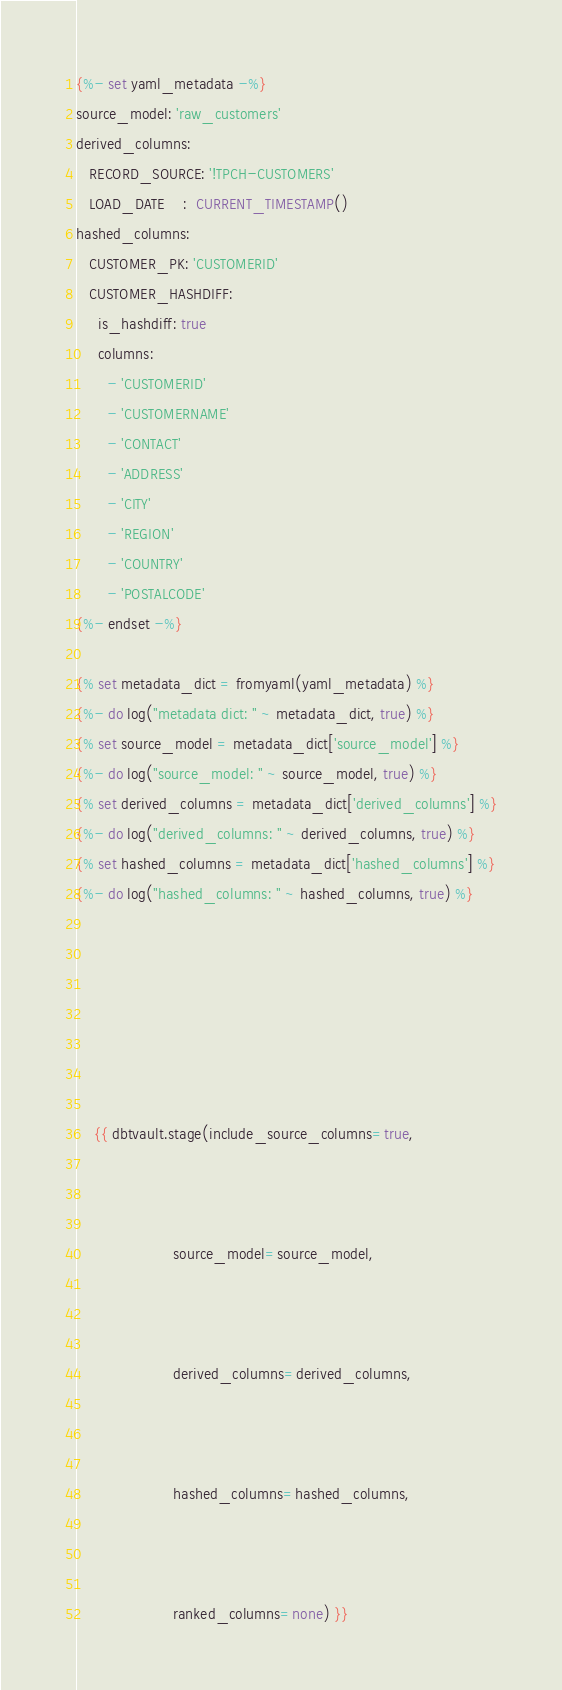Convert code to text. <code><loc_0><loc_0><loc_500><loc_500><_SQL_>{%- set yaml_metadata -%}
source_model: 'raw_customers'
derived_columns:
   RECORD_SOURCE: '!TPCH-CUSTOMERS'
   LOAD_DATE    :  CURRENT_TIMESTAMP()
hashed_columns:
   CUSTOMER_PK: 'CUSTOMERID'
   CUSTOMER_HASHDIFF:
     is_hashdiff: true
     columns:
       - 'CUSTOMERID'
       - 'CUSTOMERNAME'
       - 'CONTACT'
       - 'ADDRESS'
       - 'CITY'
       - 'REGION'
       - 'COUNTRY'
       - 'POSTALCODE'
{%- endset -%}

{% set metadata_dict = fromyaml(yaml_metadata) %}
{%- do log("metadata dict: " ~ metadata_dict, true) %}
{% set source_model = metadata_dict['source_model'] %}
{%- do log("source_model: " ~ source_model, true) %}
{% set derived_columns = metadata_dict['derived_columns'] %}
{%- do log("derived_columns: " ~ derived_columns, true) %}
{% set hashed_columns = metadata_dict['hashed_columns'] %}
{%- do log("hashed_columns: " ~ hashed_columns, true) %}







    {{ dbtvault.stage(include_source_columns=true,



                      source_model=source_model,



                      derived_columns=derived_columns,



                      hashed_columns=hashed_columns,



                      ranked_columns=none) }}






</code> 